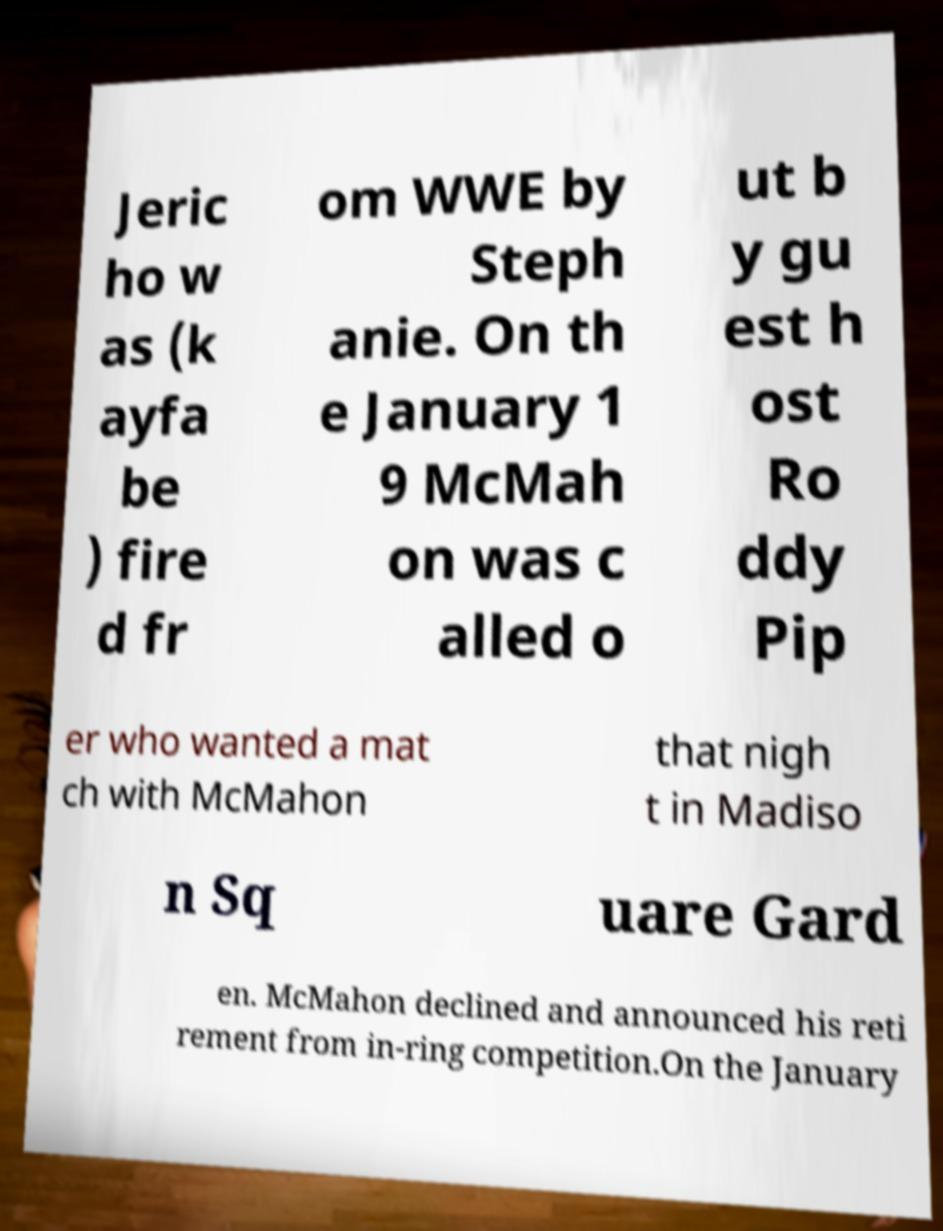Can you accurately transcribe the text from the provided image for me? Jeric ho w as (k ayfa be ) fire d fr om WWE by Steph anie. On th e January 1 9 McMah on was c alled o ut b y gu est h ost Ro ddy Pip er who wanted a mat ch with McMahon that nigh t in Madiso n Sq uare Gard en. McMahon declined and announced his reti rement from in-ring competition.On the January 